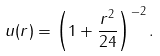Convert formula to latex. <formula><loc_0><loc_0><loc_500><loc_500>u ( r ) = \left ( 1 + \frac { r ^ { 2 } } { 2 4 } \right ) ^ { - 2 } .</formula> 